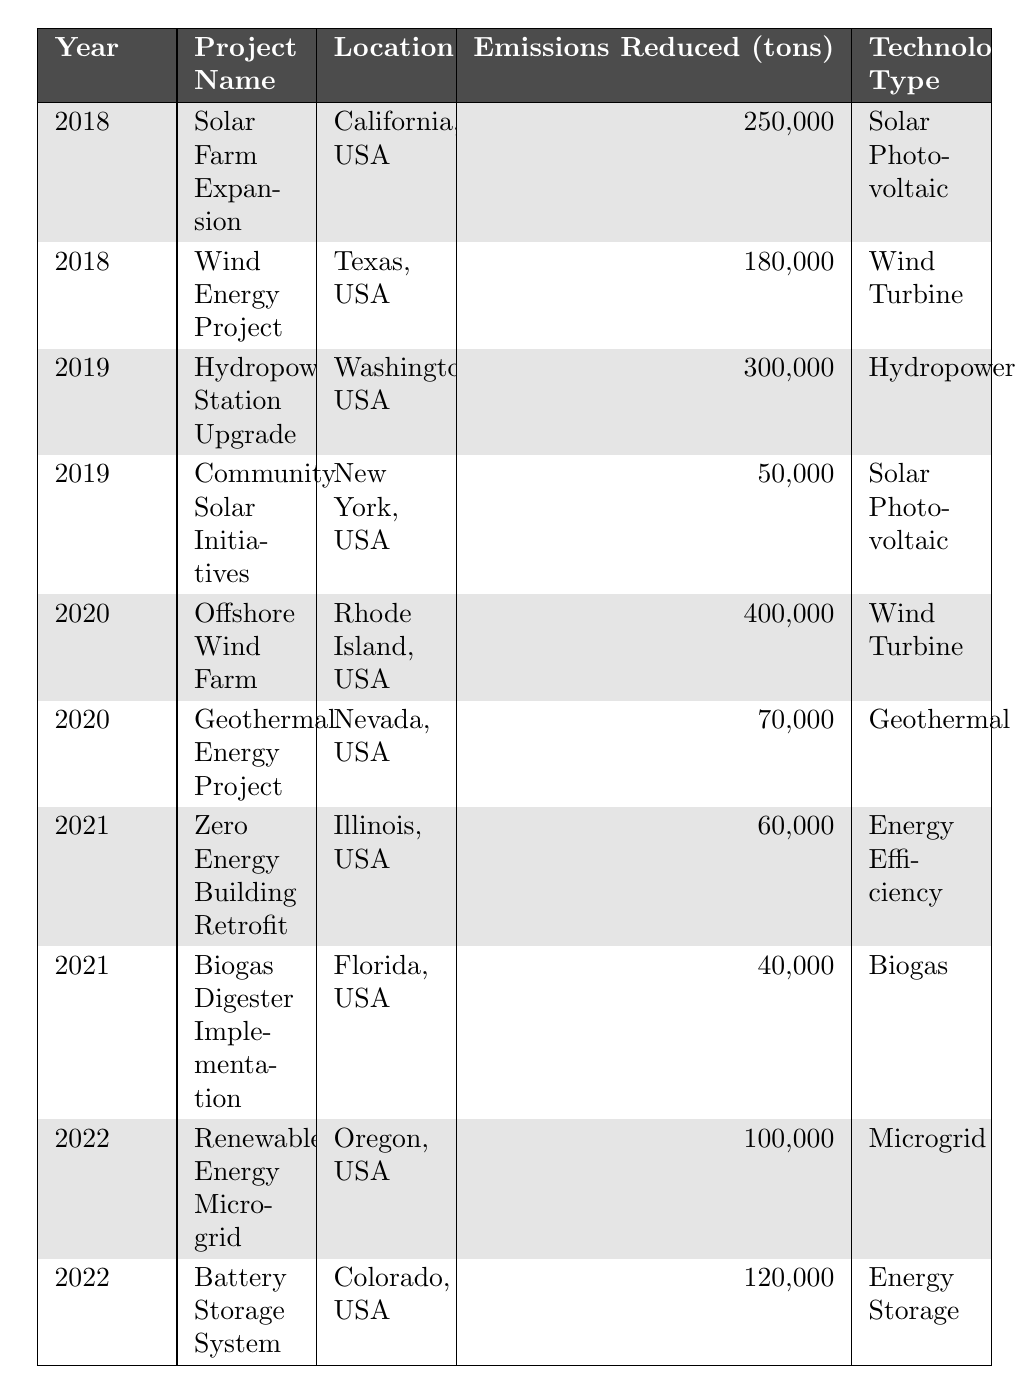What project had the highest emissions reduced in 2020? In the year 2020, there were two projects: Offshore Wind Farm with 400,000 tons and Geothermal Energy Project with 70,000 tons. The Offshore Wind Farm has the highest emissions reduction.
Answer: Offshore Wind Farm How many tons of emissions were reduced by the Wind Energy Project in 2018? The Wind Energy Project in 2018 reduced 180,000 tons of emissions, as shown directly in the table.
Answer: 180,000 tons What is the total emissions reduction from renewable energy projects in 2019? In 2019, the emissions reductions were from two projects: Hydropower Station Upgrade (300,000 tons) and Community Solar Initiatives (50,000 tons). The total is 300,000 + 50,000 = 350,000 tons.
Answer: 350,000 tons Was any project in 2021 related to Energy Efficiency? Yes, the Zero Energy Building Retrofit project in 2021 was related to Energy Efficiency, as indicated in the table.
Answer: Yes Which year had the least total emissions reduction from renewable projects? For the years given: 2018: 430,000 tons (250,000 + 180,000), 2019: 350,000 tons (300,000 + 50,000), 2020: 470,000 tons (400,000 + 70,000), 2021: 100,000 tons (60,000 + 40,000), and 2022: 220,000 tons (100,000 + 120,000). The year with the least total emissions reduction is 2021.
Answer: 2021 What type of technology had the highest emissions reduction for projects listed in 2019? In 2019, the Hydropower Station Upgrade (300,000 tons) used Hydropower technology, while Community Solar Initiatives (50,000 tons) used Solar Photovoltaic. Therefore, Hydropower had the highest emissions reduction that year.
Answer: Hydropower What is the average emissions reduction for the projects listed in 2022? In 2022, the emissions reductions were 100,000 tons from the Renewable Energy Microgrid and 120,000 tons from the Battery Storage System. The average is (100,000 + 120,000) / 2 = 110,000 tons.
Answer: 110,000 tons Which state had the highest emissions reduction project in 2018? In 2018, the Solar Farm Expansion in California reduced 250,000 tons, which is higher than the Wind Energy Project in Texas (180,000 tons). Therefore, California had the highest emissions reduction project that year.
Answer: California Did the emissions reduced by projects in 2020 exceed the combined emissions of all 2021 projects? In 2020, emissions reduced were 470,000 tons (400,000 + 70,000). In 2021, it was 100,000 tons (60,000 + 40,000). Since 470,000 > 100,000, the statement is true.
Answer: Yes What was the total emissions reduction from all projects listed in 2018? The total emissions reduction in 2018 consists of 250,000 tons from Solar Farm Expansion and 180,000 tons from Wind Energy Project. The total is 250,000 + 180,000 = 430,000 tons.
Answer: 430,000 tons Which technology type had the lowest emissions reduction total across the years? By reviewing the total emissions reductions for each technology: Solar Photovoltaic (300,000), Wind Turbine (580,000), Hydropower (300,000), Geothermal (70,000), Energy Efficiency (60,000), Biogas (40,000), Microgrid (100,000), Energy Storage (120,000). The lowest total is for Biogas with 40,000 tons.
Answer: Biogas 